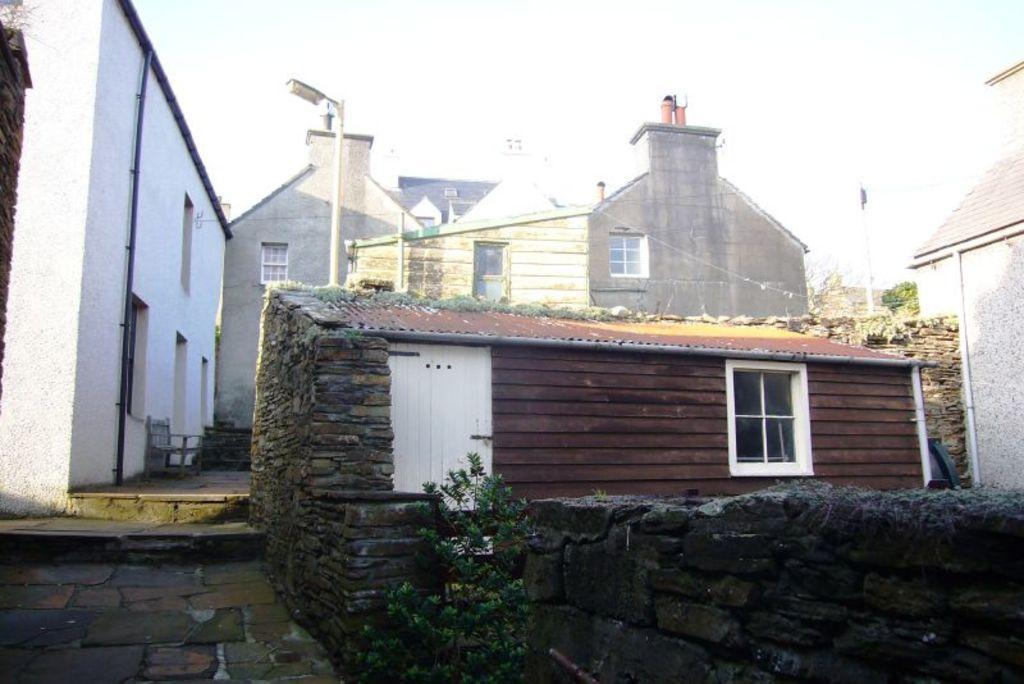How would you summarize this image in a sentence or two? In the foreground of the picture there are walls, house, door, window. In the center of the picture there are houses, street light, pole and trees. On the left there is a chair. 